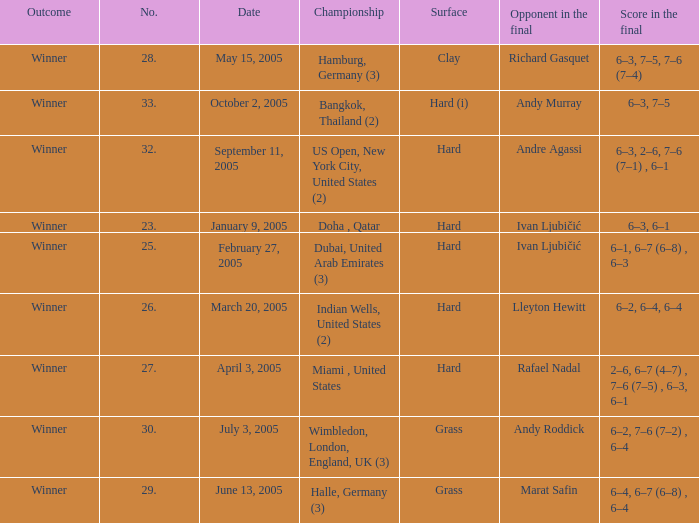Marat Safin is the opponent in the final in what championship? Halle, Germany (3). 